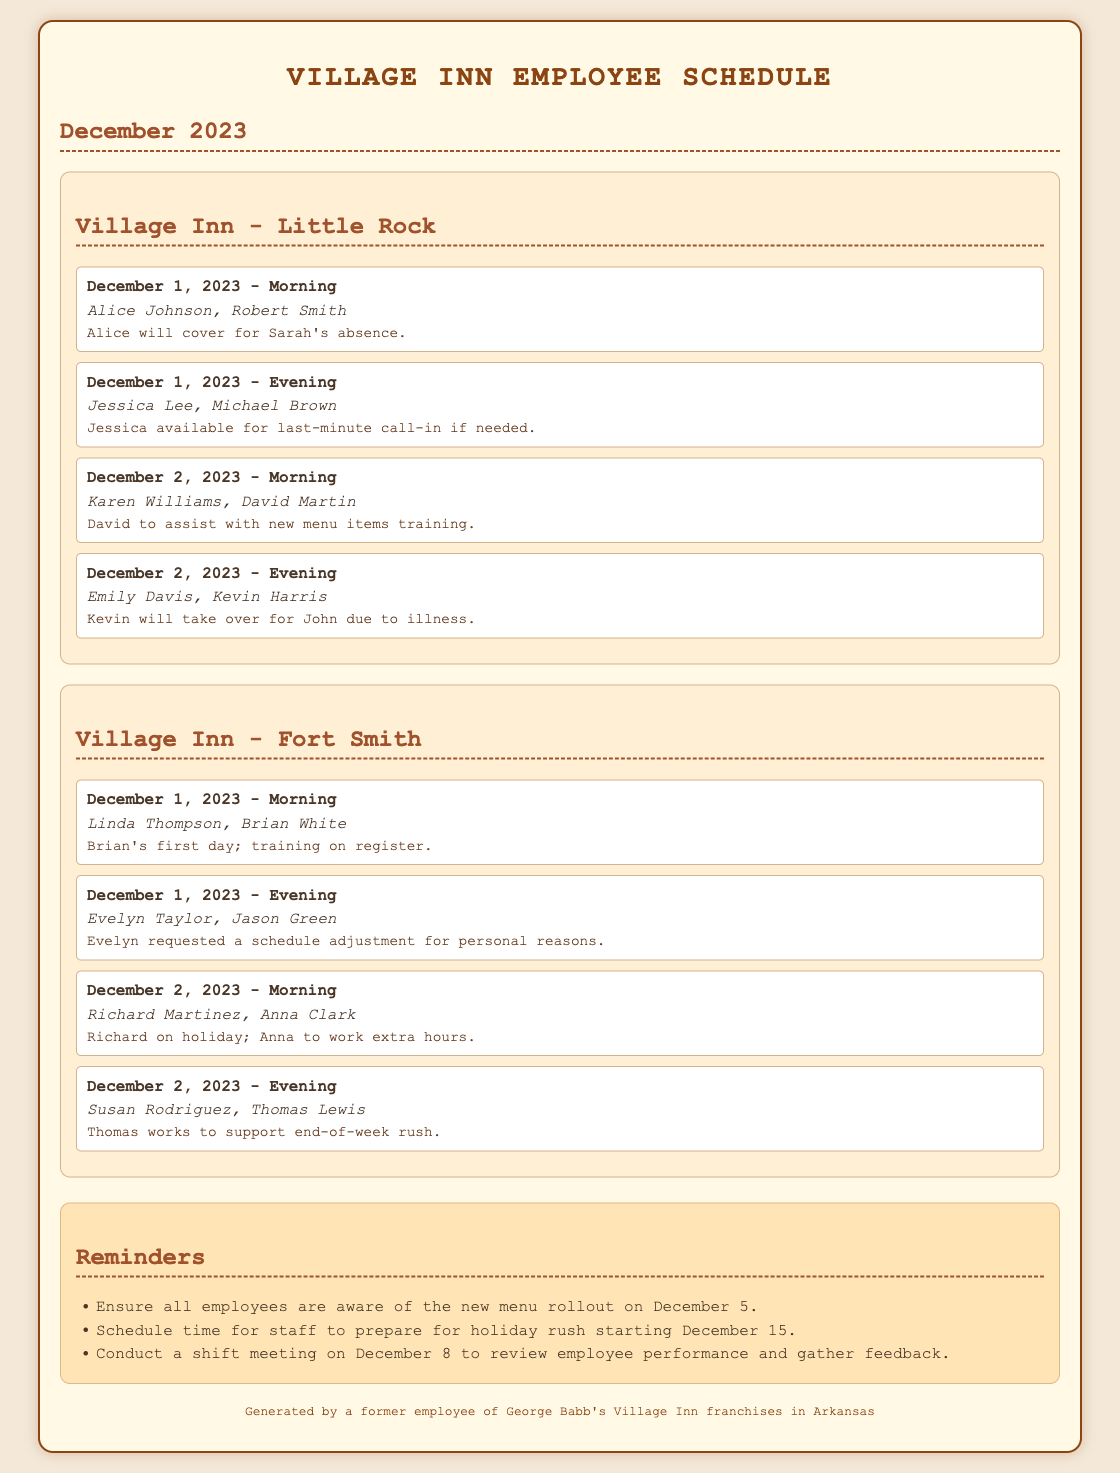What employees are scheduled for the morning shift on December 1, 2023, in Little Rock? The morning shift on December 1, 2023, in Little Rock includes Alice Johnson and Robert Smith.
Answer: Alice Johnson, Robert Smith Who is covering for Sarah's absence? Alice Johnson is covering for Sarah's absence as noted in the coverage section.
Answer: Alice On what date is the new menu rollout? The new menu rollout is scheduled for December 5, as mentioned in the reminders section.
Answer: December 5 Which employee is working extra hours on December 2, 2023, in Fort Smith? Anna Clark is working extra hours while Richard Martinez is on holiday.
Answer: Anna Clark What type of meeting is scheduled for December 8? A shift meeting is scheduled on December 8 to review employee performance and gather feedback.
Answer: Shift meeting How many employees are scheduled for the evening shift on December 1, 2023, in Fort Smith? The evening shift on December 1, 2023, in Fort Smith has two employees: Evelyn Taylor and Jason Green.
Answer: Two What is the reason for Evelyn Taylor's schedule adjustment? Evelyn requested a schedule adjustment for personal reasons, as indicated in the coverage notes.
Answer: Personal reasons Who will assist with training on new menu items on December 2, 2023? David Martin will assist with training on new menu items as noted in the shift for December 2 morning.
Answer: David Martin 